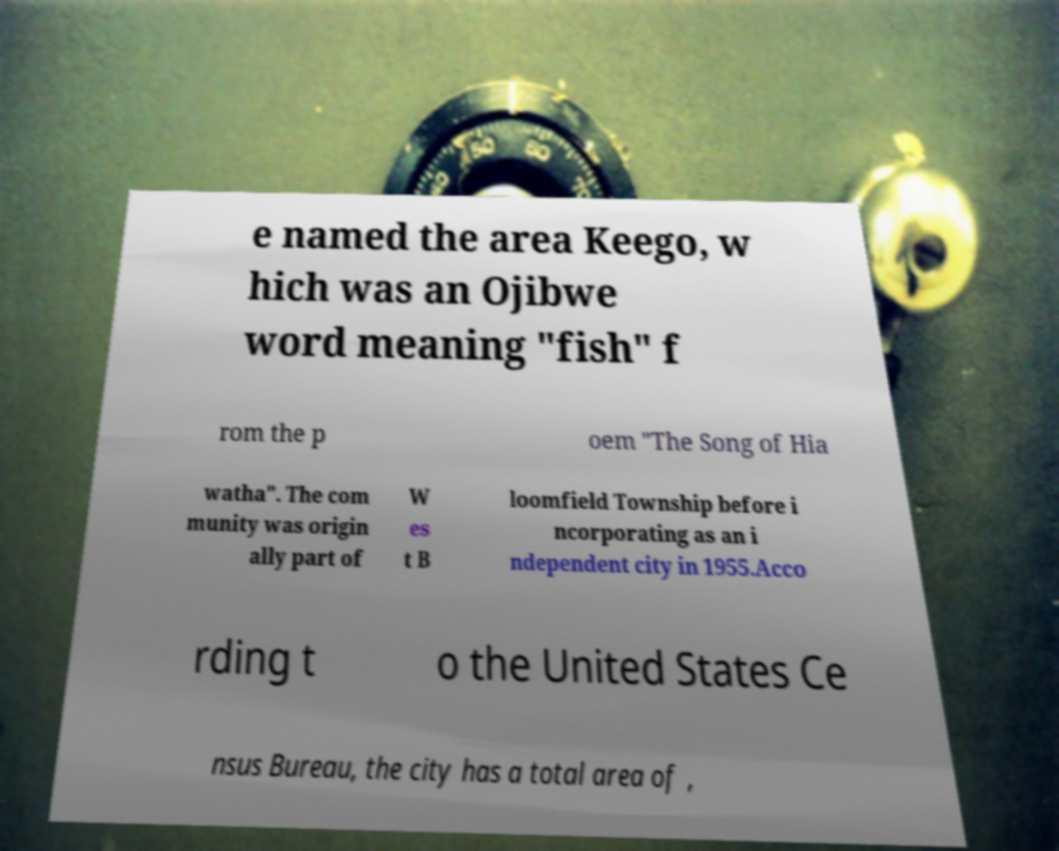Please read and relay the text visible in this image. What does it say? e named the area Keego, w hich was an Ojibwe word meaning "fish" f rom the p oem "The Song of Hia watha". The com munity was origin ally part of W es t B loomfield Township before i ncorporating as an i ndependent city in 1955.Acco rding t o the United States Ce nsus Bureau, the city has a total area of , 